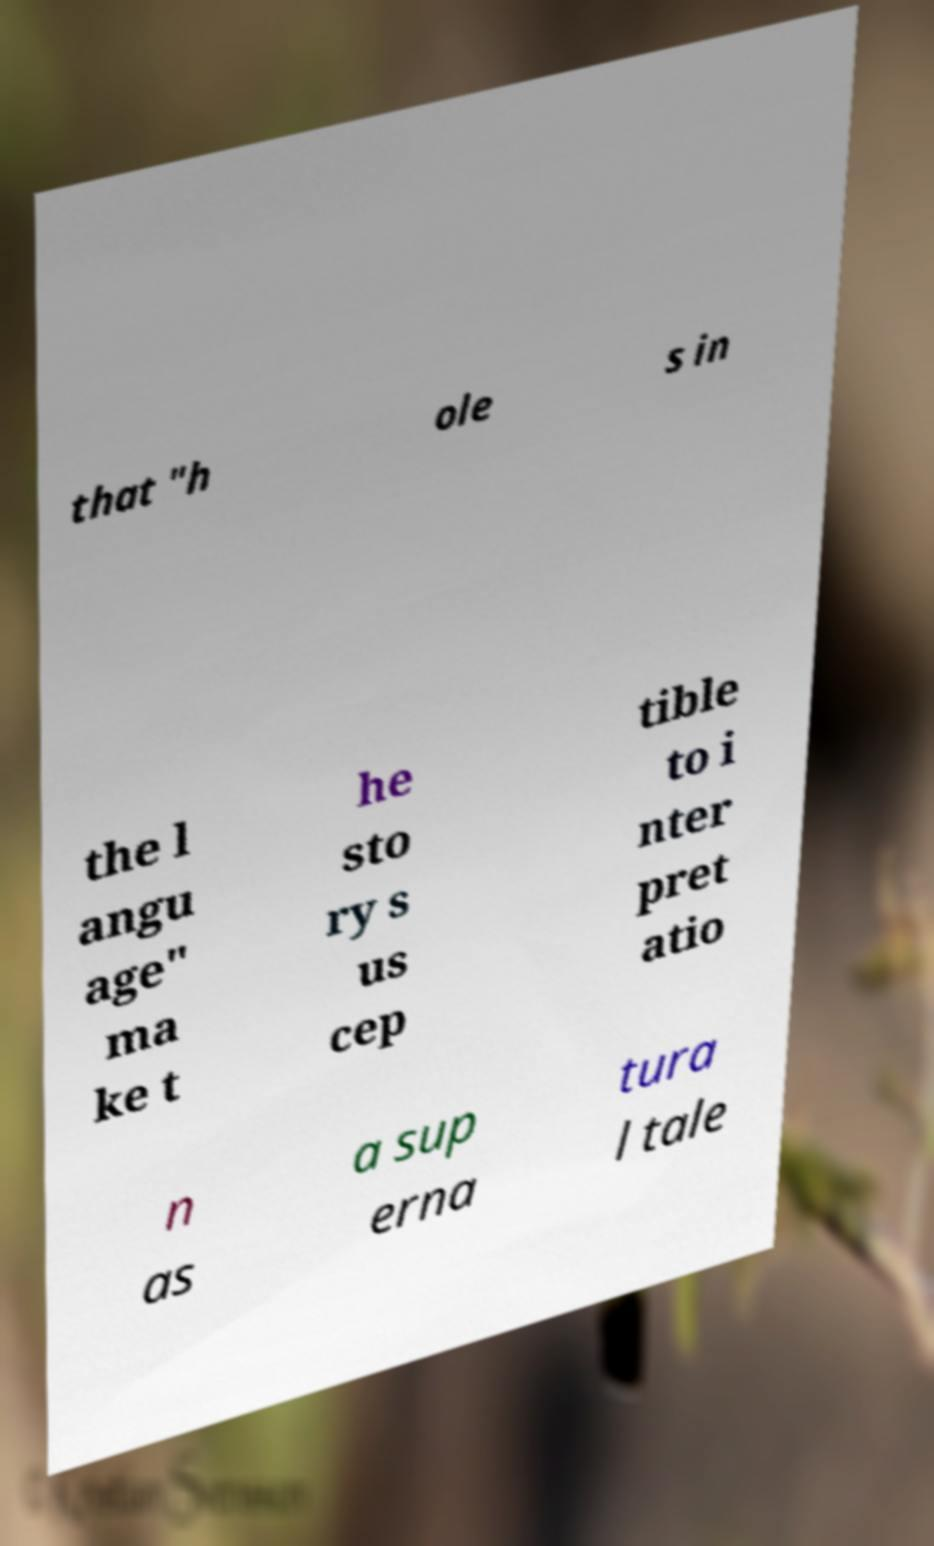I need the written content from this picture converted into text. Can you do that? that "h ole s in the l angu age" ma ke t he sto ry s us cep tible to i nter pret atio n as a sup erna tura l tale 